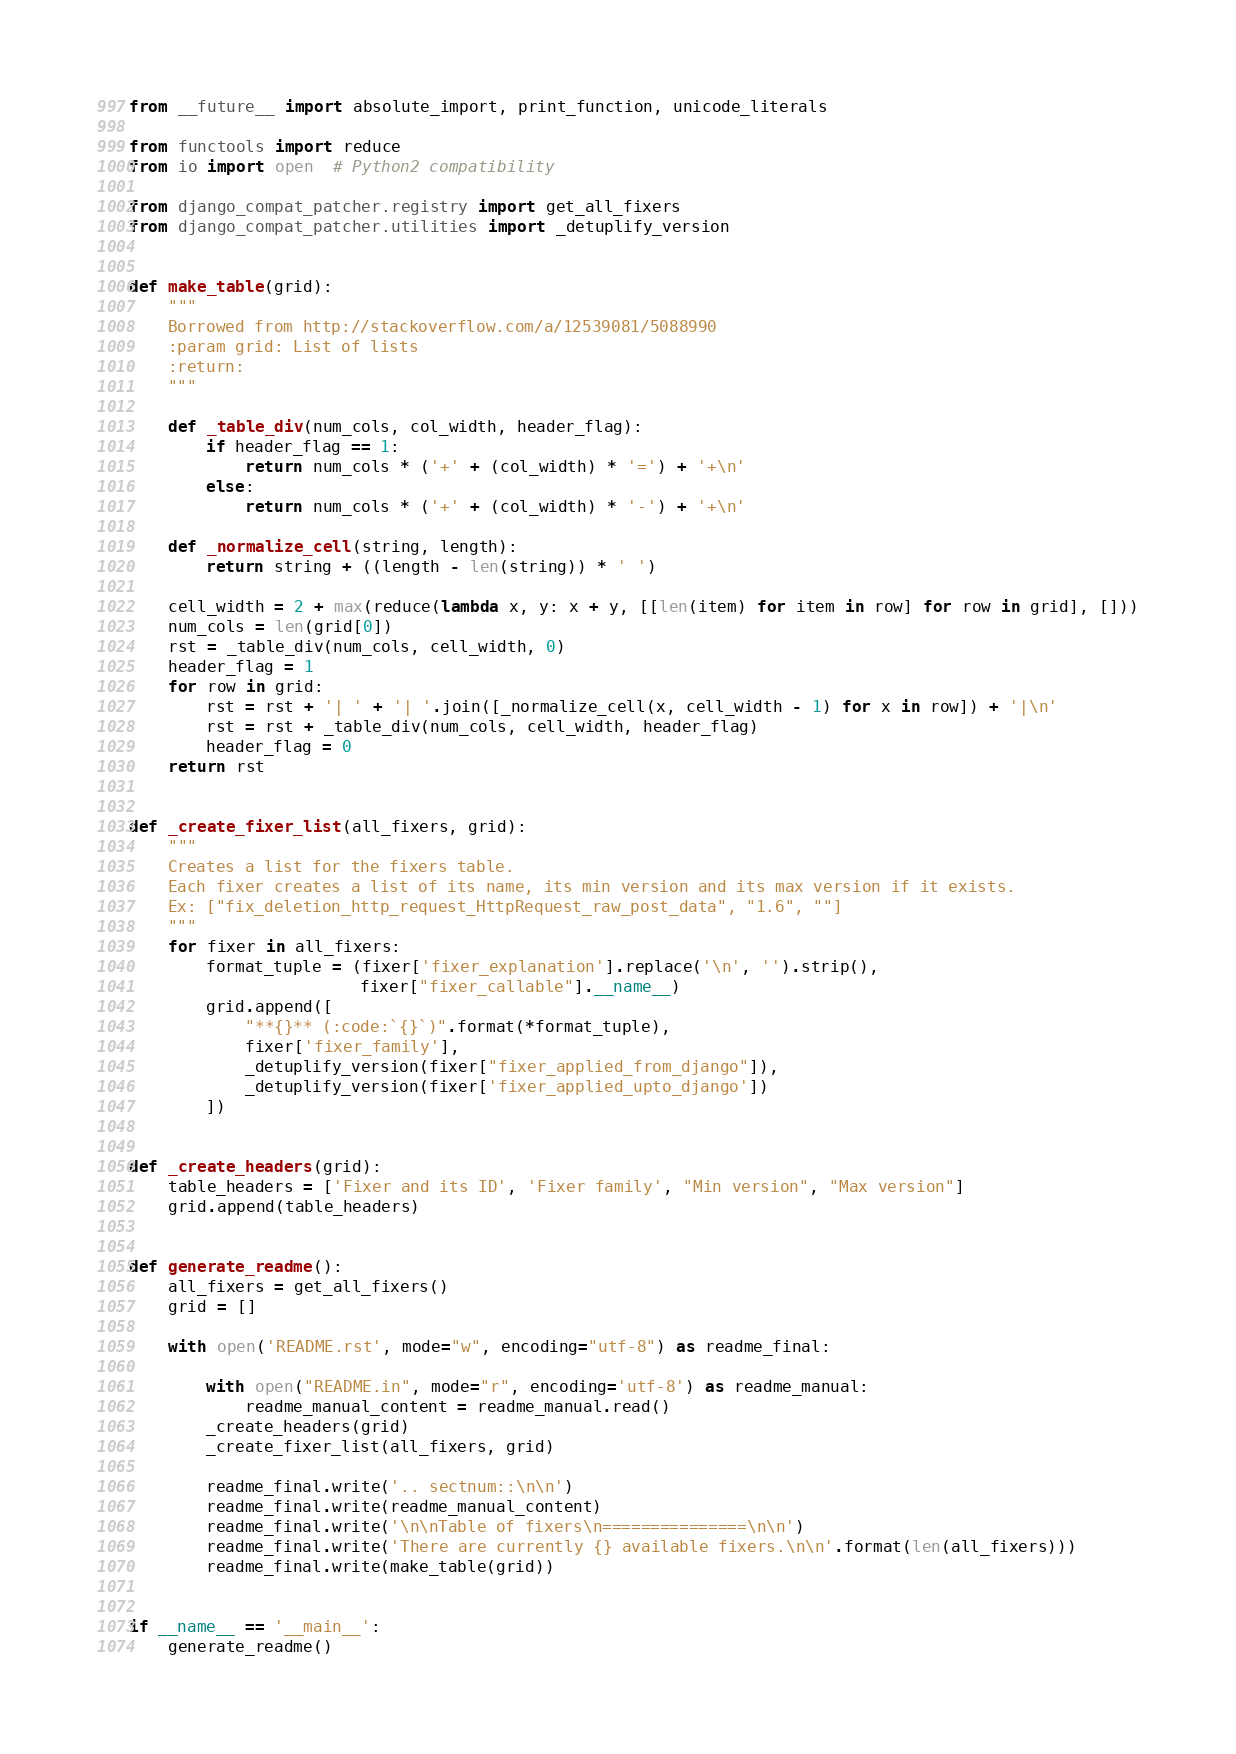<code> <loc_0><loc_0><loc_500><loc_500><_Python_>from __future__ import absolute_import, print_function, unicode_literals

from functools import reduce
from io import open  # Python2 compatibility

from django_compat_patcher.registry import get_all_fixers
from django_compat_patcher.utilities import _detuplify_version


def make_table(grid):
    """
    Borrowed from http://stackoverflow.com/a/12539081/5088990
    :param grid: List of lists
    :return:
    """

    def _table_div(num_cols, col_width, header_flag):
        if header_flag == 1:
            return num_cols * ('+' + (col_width) * '=') + '+\n'
        else:
            return num_cols * ('+' + (col_width) * '-') + '+\n'

    def _normalize_cell(string, length):
        return string + ((length - len(string)) * ' ')

    cell_width = 2 + max(reduce(lambda x, y: x + y, [[len(item) for item in row] for row in grid], []))
    num_cols = len(grid[0])
    rst = _table_div(num_cols, cell_width, 0)
    header_flag = 1
    for row in grid:
        rst = rst + '| ' + '| '.join([_normalize_cell(x, cell_width - 1) for x in row]) + '|\n'
        rst = rst + _table_div(num_cols, cell_width, header_flag)
        header_flag = 0
    return rst


def _create_fixer_list(all_fixers, grid):
    """
    Creates a list for the fixers table.
    Each fixer creates a list of its name, its min version and its max version if it exists.
    Ex: ["fix_deletion_http_request_HttpRequest_raw_post_data", "1.6", ""]
    """
    for fixer in all_fixers:
        format_tuple = (fixer['fixer_explanation'].replace('\n', '').strip(),
                        fixer["fixer_callable"].__name__)
        grid.append([
            "**{}** (:code:`{}`)".format(*format_tuple),
            fixer['fixer_family'],
            _detuplify_version(fixer["fixer_applied_from_django"]),
            _detuplify_version(fixer['fixer_applied_upto_django'])
        ])


def _create_headers(grid):
    table_headers = ['Fixer and its ID', 'Fixer family', "Min version", "Max version"]
    grid.append(table_headers)


def generate_readme():
    all_fixers = get_all_fixers()
    grid = []

    with open('README.rst', mode="w", encoding="utf-8") as readme_final:

        with open("README.in", mode="r", encoding='utf-8') as readme_manual:
            readme_manual_content = readme_manual.read()
        _create_headers(grid)
        _create_fixer_list(all_fixers, grid)

        readme_final.write('.. sectnum::\n\n')
        readme_final.write(readme_manual_content)
        readme_final.write('\n\nTable of fixers\n===============\n\n')
        readme_final.write('There are currently {} available fixers.\n\n'.format(len(all_fixers)))
        readme_final.write(make_table(grid))


if __name__ == '__main__':
    generate_readme()
</code> 